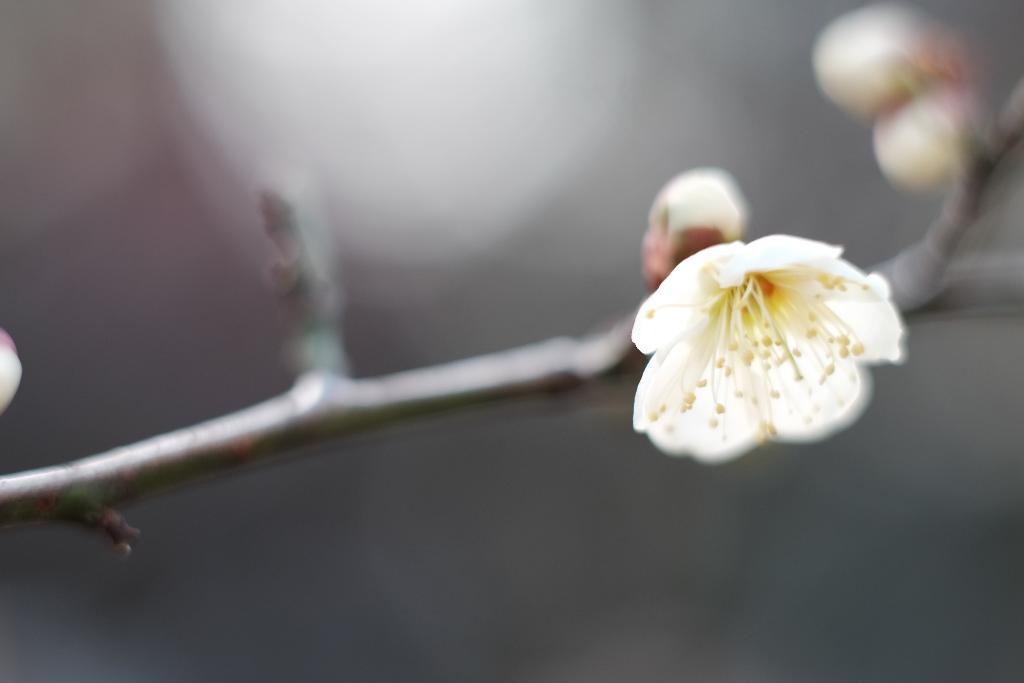What type of plants can be seen in the image? There are flowers in the image. What part of the flowers is visible in the image? There are stems in the image. What type of humor can be seen in the image? There is no humor present in the image; it features flowers and stems. Is there any grass visible in the image? There is no grass visible in the image; it only features flowers and stems. 